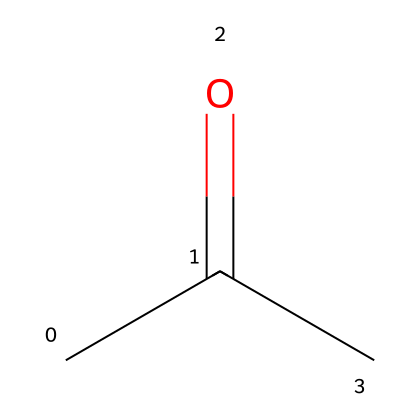What is the molecular formula of acetone? The SMILES representation CC(=O)C indicates that the molecule contains 3 carbon atoms (C), 6 hydrogen atoms (H), and 1 oxygen atom (O). Therefore, the molecular formula can be derived as C3H6O.
Answer: C3H6O How many carbon atoms are present in the structure? By analyzing the SMILES representation, there are two `C` symbols before the `=O` (indicating a carbonyl group) and one `C` after it, totaling three carbon atoms.
Answer: 3 What types of chemical bonds are present in acetone? The structure includes single bonds between the carbon atoms (C-C) and a double bond between one carbon and the oxygen atom (C=O). This indicates both single and double bonds are present in the molecule.
Answer: single and double Why is acetone considered a good solvent? Acetone possesses a polar structure due to the presence of the carbonyl group (C=O), which allows it to effectively dissolve many polar and non-polar compounds commonly used in military applications.
Answer: polar structure What is the functional group in acetone? The functional group present in acetone is the carbonyl group, indicated by the `=O` in the SMILES representation, which defines it as a ketone.
Answer: carbonyl group How does the structure of acetone affect its volatility? The molecular structure of acetone, with its small size and polar functional group, leads to relatively low intermolecular forces, allowing acetone to evaporate easily and thus making it highly volatile.
Answer: low intermolecular forces 